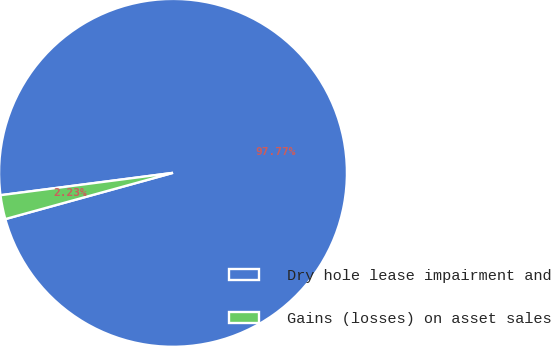Convert chart. <chart><loc_0><loc_0><loc_500><loc_500><pie_chart><fcel>Dry hole lease impairment and<fcel>Gains (losses) on asset sales<nl><fcel>97.77%<fcel>2.23%<nl></chart> 